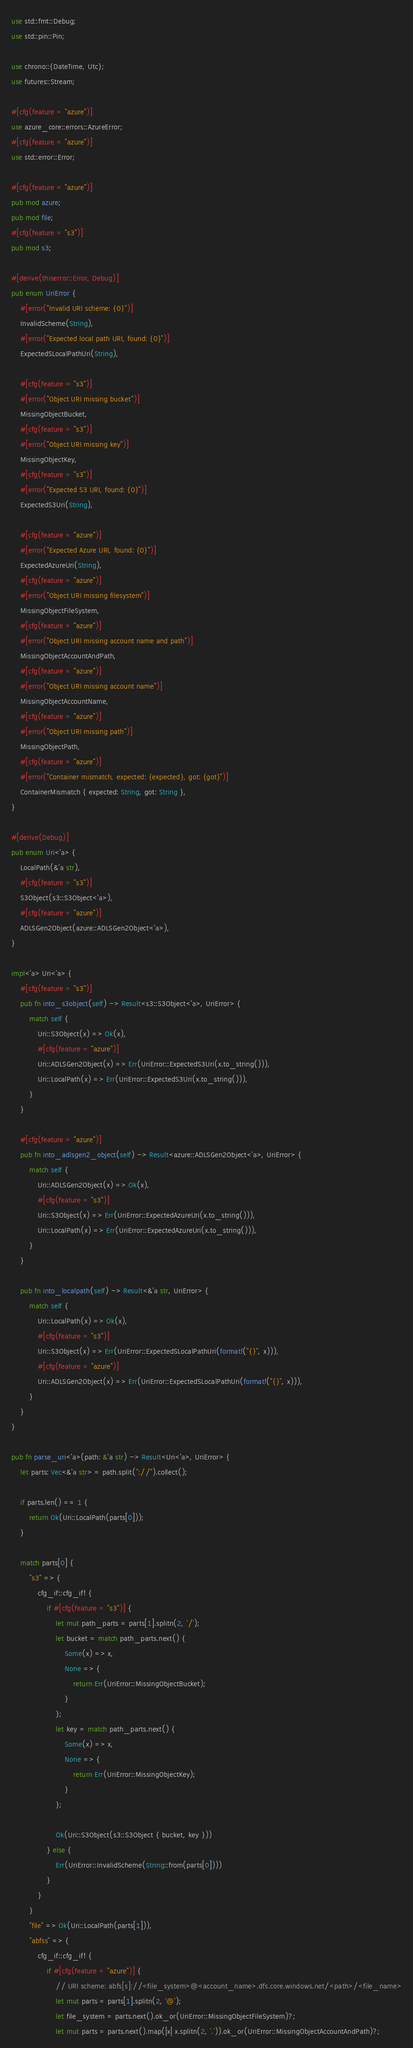<code> <loc_0><loc_0><loc_500><loc_500><_Rust_>use std::fmt::Debug;
use std::pin::Pin;

use chrono::{DateTime, Utc};
use futures::Stream;

#[cfg(feature = "azure")]
use azure_core::errors::AzureError;
#[cfg(feature = "azure")]
use std::error::Error;

#[cfg(feature = "azure")]
pub mod azure;
pub mod file;
#[cfg(feature = "s3")]
pub mod s3;

#[derive(thiserror::Error, Debug)]
pub enum UriError {
    #[error("Invalid URI scheme: {0}")]
    InvalidScheme(String),
    #[error("Expected local path URI, found: {0}")]
    ExpectedSLocalPathUri(String),

    #[cfg(feature = "s3")]
    #[error("Object URI missing bucket")]
    MissingObjectBucket,
    #[cfg(feature = "s3")]
    #[error("Object URI missing key")]
    MissingObjectKey,
    #[cfg(feature = "s3")]
    #[error("Expected S3 URI, found: {0}")]
    ExpectedS3Uri(String),

    #[cfg(feature = "azure")]
    #[error("Expected Azure URI, found: {0}")]
    ExpectedAzureUri(String),
    #[cfg(feature = "azure")]
    #[error("Object URI missing filesystem")]
    MissingObjectFileSystem,
    #[cfg(feature = "azure")]
    #[error("Object URI missing account name and path")]
    MissingObjectAccountAndPath,
    #[cfg(feature = "azure")]
    #[error("Object URI missing account name")]
    MissingObjectAccountName,
    #[cfg(feature = "azure")]
    #[error("Object URI missing path")]
    MissingObjectPath,
    #[cfg(feature = "azure")]
    #[error("Container mismatch, expected: {expected}, got: {got}")]
    ContainerMismatch { expected: String, got: String },
}

#[derive(Debug)]
pub enum Uri<'a> {
    LocalPath(&'a str),
    #[cfg(feature = "s3")]
    S3Object(s3::S3Object<'a>),
    #[cfg(feature = "azure")]
    ADLSGen2Object(azure::ADLSGen2Object<'a>),
}

impl<'a> Uri<'a> {
    #[cfg(feature = "s3")]
    pub fn into_s3object(self) -> Result<s3::S3Object<'a>, UriError> {
        match self {
            Uri::S3Object(x) => Ok(x),
            #[cfg(feature = "azure")]
            Uri::ADLSGen2Object(x) => Err(UriError::ExpectedS3Uri(x.to_string())),
            Uri::LocalPath(x) => Err(UriError::ExpectedS3Uri(x.to_string())),
        }
    }

    #[cfg(feature = "azure")]
    pub fn into_adlsgen2_object(self) -> Result<azure::ADLSGen2Object<'a>, UriError> {
        match self {
            Uri::ADLSGen2Object(x) => Ok(x),
            #[cfg(feature = "s3")]
            Uri::S3Object(x) => Err(UriError::ExpectedAzureUri(x.to_string())),
            Uri::LocalPath(x) => Err(UriError::ExpectedAzureUri(x.to_string())),
        }
    }

    pub fn into_localpath(self) -> Result<&'a str, UriError> {
        match self {
            Uri::LocalPath(x) => Ok(x),
            #[cfg(feature = "s3")]
            Uri::S3Object(x) => Err(UriError::ExpectedSLocalPathUri(format!("{}", x))),
            #[cfg(feature = "azure")]
            Uri::ADLSGen2Object(x) => Err(UriError::ExpectedSLocalPathUri(format!("{}", x))),
        }
    }
}

pub fn parse_uri<'a>(path: &'a str) -> Result<Uri<'a>, UriError> {
    let parts: Vec<&'a str> = path.split("://").collect();

    if parts.len() == 1 {
        return Ok(Uri::LocalPath(parts[0]));
    }

    match parts[0] {
        "s3" => {
            cfg_if::cfg_if! {
                if #[cfg(feature = "s3")] {
                    let mut path_parts = parts[1].splitn(2, '/');
                    let bucket = match path_parts.next() {
                        Some(x) => x,
                        None => {
                            return Err(UriError::MissingObjectBucket);
                        }
                    };
                    let key = match path_parts.next() {
                        Some(x) => x,
                        None => {
                            return Err(UriError::MissingObjectKey);
                        }
                    };

                    Ok(Uri::S3Object(s3::S3Object { bucket, key }))
                } else {
                    Err(UriError::InvalidScheme(String::from(parts[0])))
                }
            }
        }
        "file" => Ok(Uri::LocalPath(parts[1])),
        "abfss" => {
            cfg_if::cfg_if! {
                if #[cfg(feature = "azure")] {
                    // URI scheme: abfs[s]://<file_system>@<account_name>.dfs.core.windows.net/<path>/<file_name>
                    let mut parts = parts[1].splitn(2, '@');
                    let file_system = parts.next().ok_or(UriError::MissingObjectFileSystem)?;
                    let mut parts = parts.next().map(|x| x.splitn(2, '.')).ok_or(UriError::MissingObjectAccountAndPath)?;</code> 